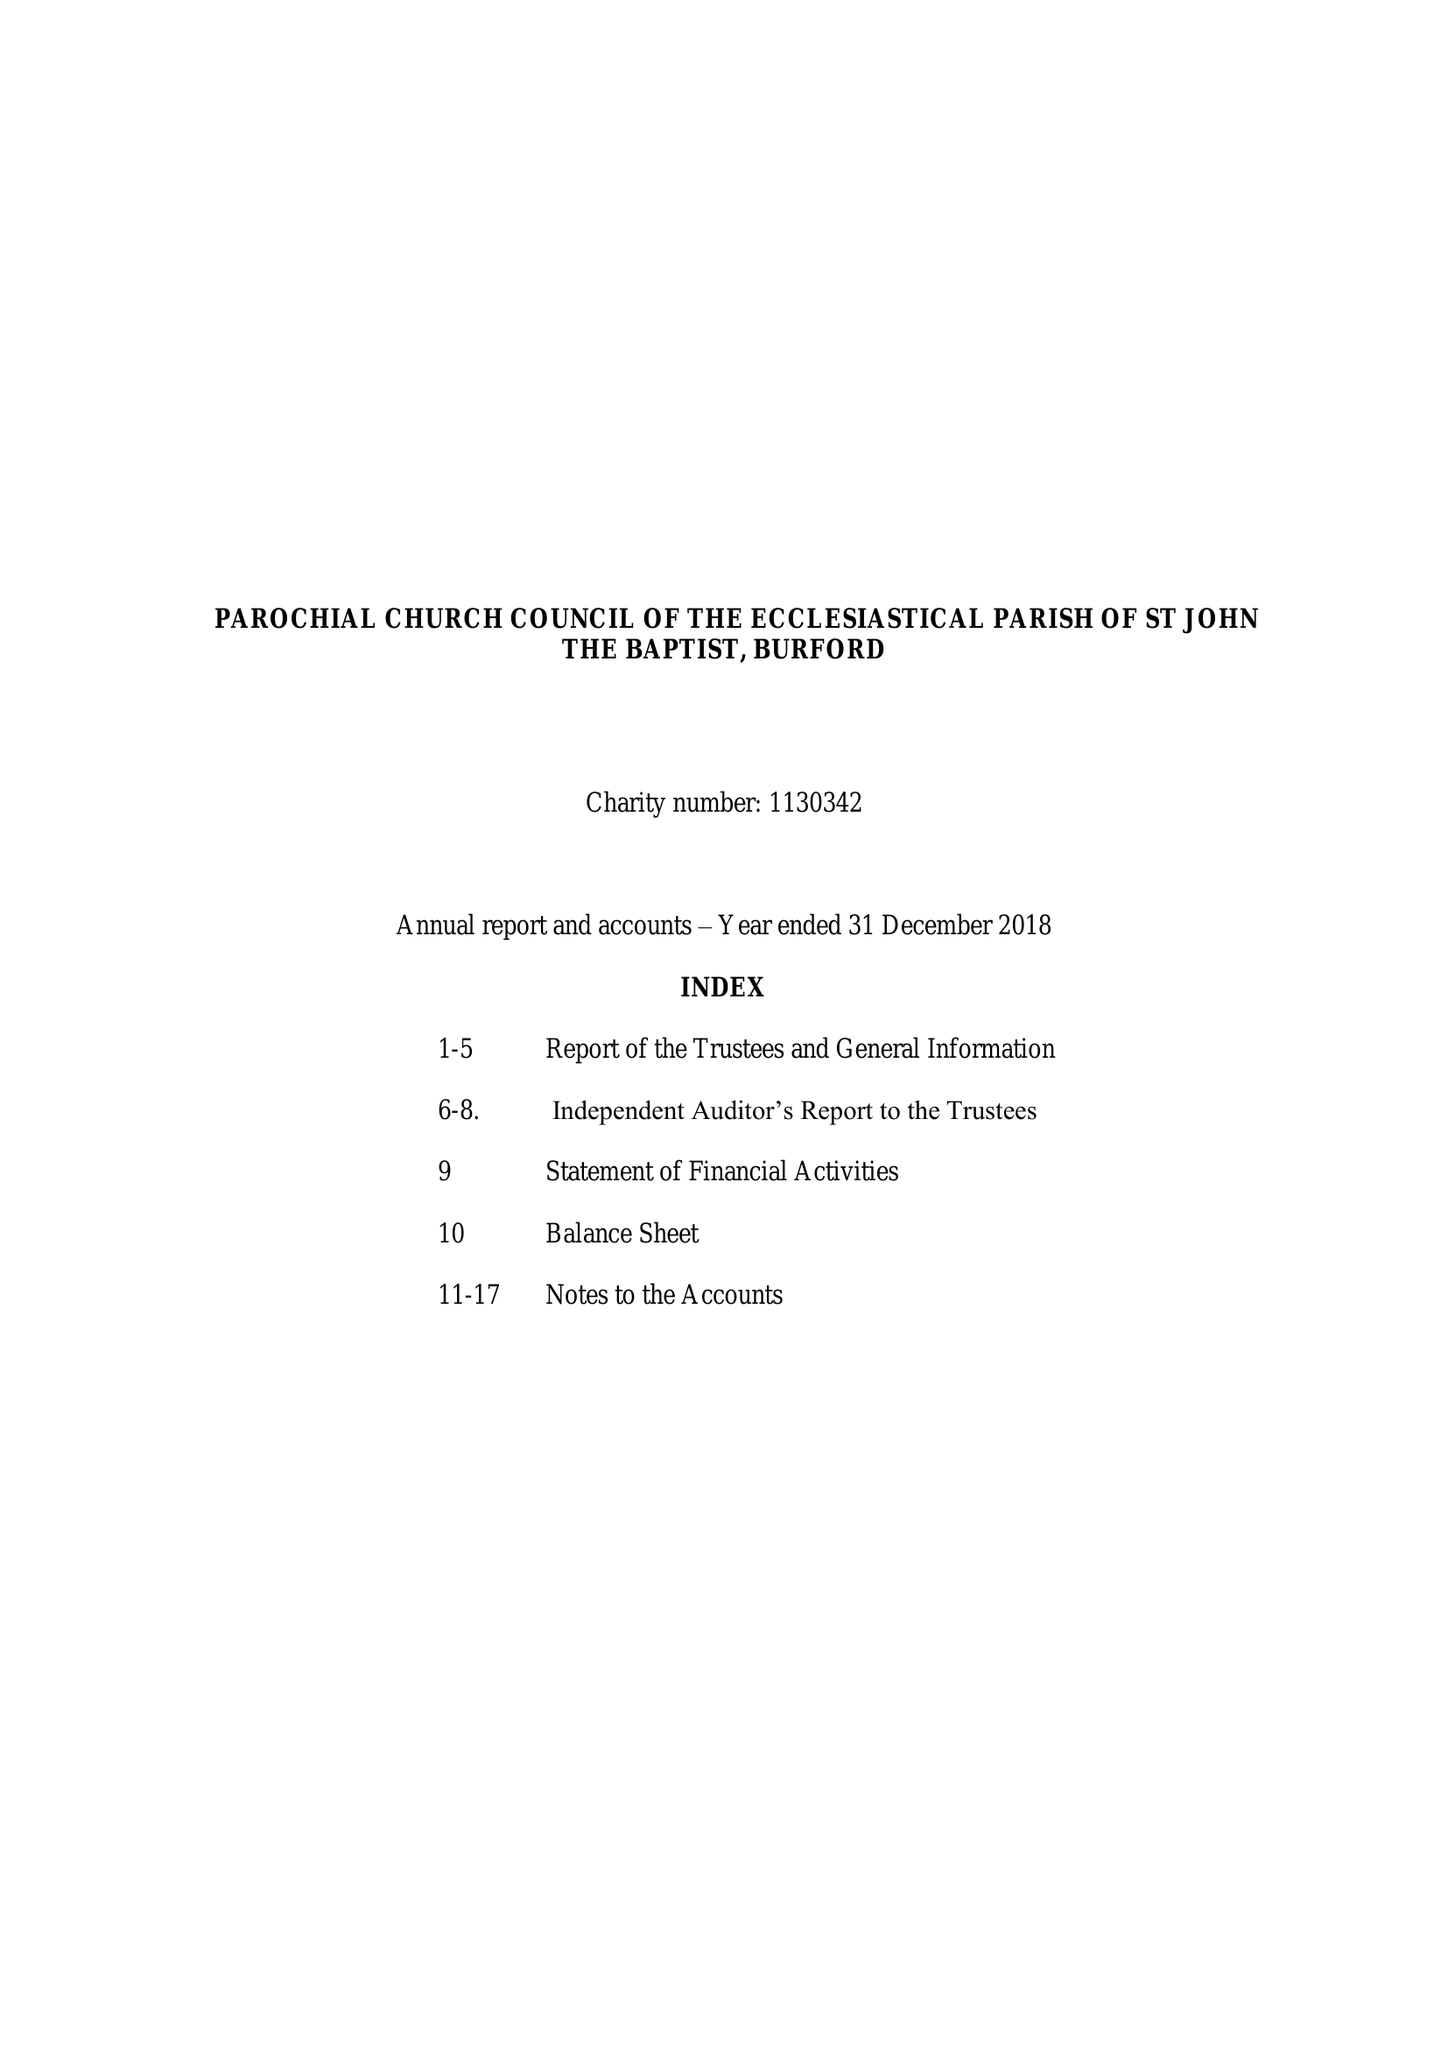What is the value for the spending_annually_in_british_pounds?
Answer the question using a single word or phrase. 537520.00 